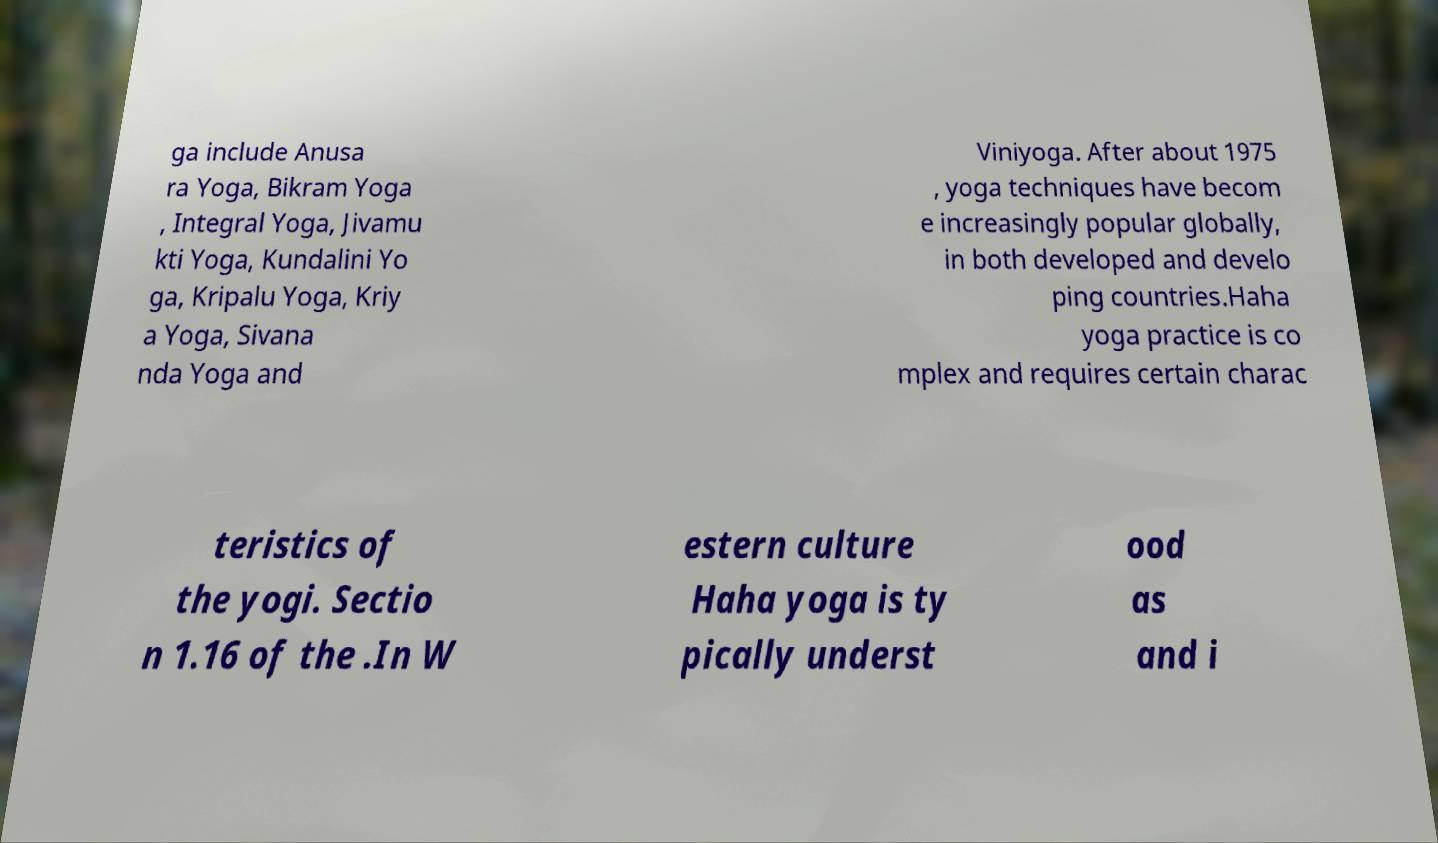Could you assist in decoding the text presented in this image and type it out clearly? ga include Anusa ra Yoga, Bikram Yoga , Integral Yoga, Jivamu kti Yoga, Kundalini Yo ga, Kripalu Yoga, Kriy a Yoga, Sivana nda Yoga and Viniyoga. After about 1975 , yoga techniques have becom e increasingly popular globally, in both developed and develo ping countries.Haha yoga practice is co mplex and requires certain charac teristics of the yogi. Sectio n 1.16 of the .In W estern culture Haha yoga is ty pically underst ood as and i 